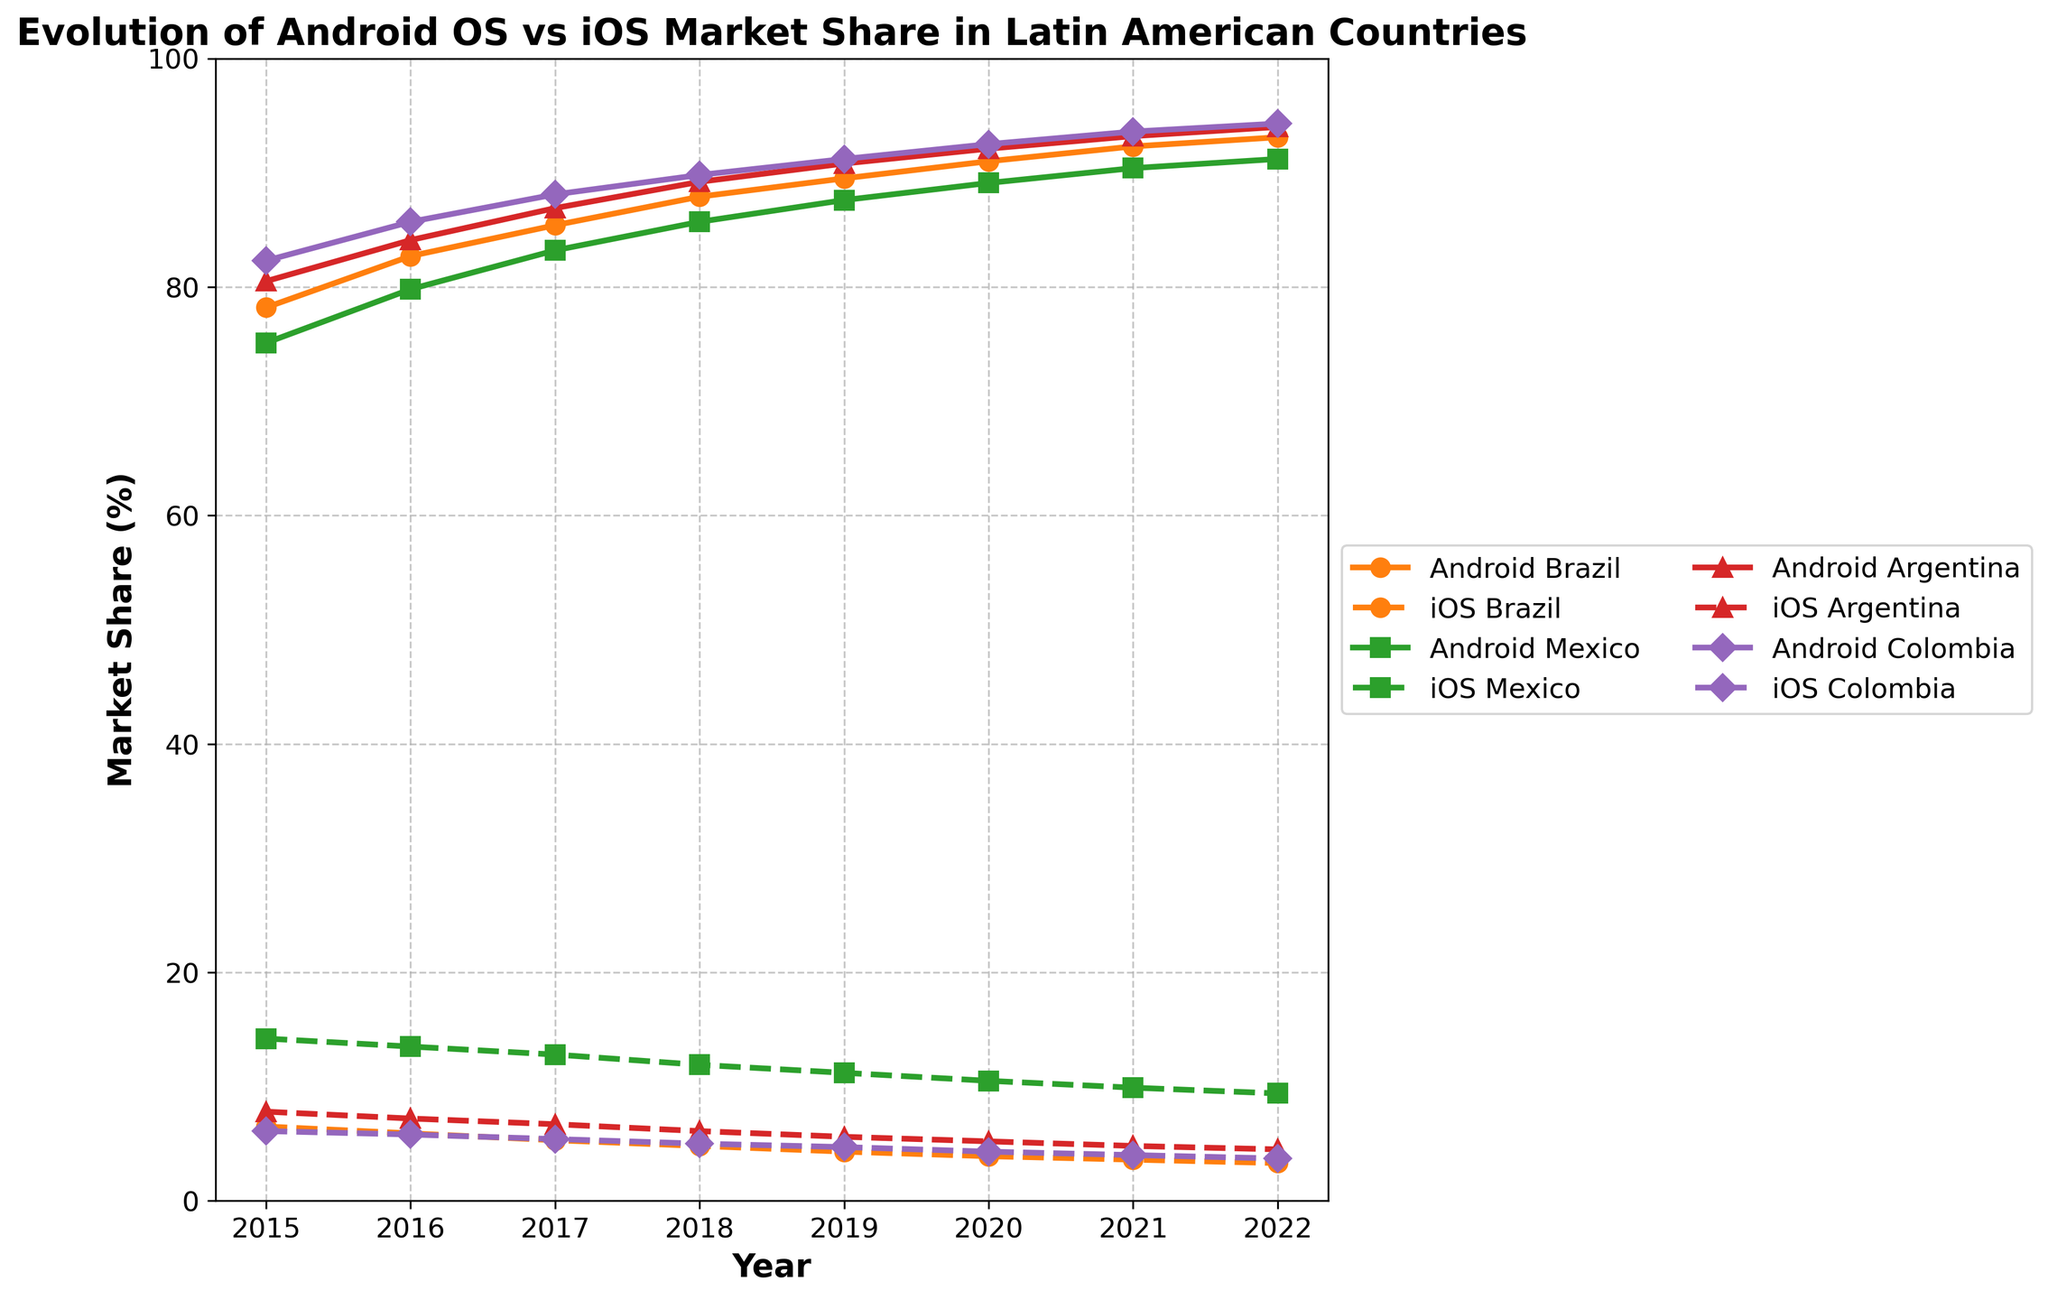How does the market share of Android in Brazil compare to iOS in 2015? In 2015, the market share of Android in Brazil was 78.2% while for iOS it was 6.5%. Comparing these values, Android had a significantly higher market share.
Answer: Android had a significantly higher market share Between 2018 and 2022, which country showed the greatest increase in Android market share? To find the greatest increase, subtract the 2018 Android market share from the 2022 value for each country: Brazil (93.1 - 87.9 = 5.2%), Mexico (91.2 - 85.7 = 5.5%), Argentina (94.0 - 89.2 = 4.8%), and Colombia (94.3 - 89.8 = 4.5%). Mexico showed the greatest increase.
Answer: Mexico Which country had the highest market share for iOS in 2022? By comparing the iOS market share in 2022 across all countries, Brazil = 3.3%, Mexico = 9.4%, Argentina = 4.5%, and Colombia = 3.7%. Mexico had the highest market share for iOS.
Answer: Mexico In which year did Android surpass 90% market share in Argentina? By looking at the data for Argentina, Android surpassed 90% market share in 2019 (90.8%).
Answer: 2019 Compare the growth trend of Android market share in Brazil and Colombia from 2015 to 2022. Both Brazil and Colombia show a steady increase in Android market share over the years. Starting at 78.2% in 2015 for Brazil and reaching 93.1% in 2022. For Colombia, it started at 82.3% in 2015 and reached 94.3% in 2022. While both trends are increasing, Colombia had a slightly higher growth rate.
Answer: Both increasing, but Colombia's growth rate was slightly higher What was the difference in market share between Android and iOS in Mexico in 2020? In 2020, Android market share in Mexico was 89.1% while iOS was 10.5%. The difference is calculated as 89.1% - 10.5% = 78.6%.
Answer: 78.6% On average, what was the iOS market share in Brazil over the given years? To find the average iOS market share in Brazil: (6.5 + 5.9 + 5.3 + 4.8 + 4.3 + 3.9 + 3.6 + 3.3) / 8 = 4.7%.
Answer: 4.7% In which year did iOS market share in Mexico drop below 10%? According to the data, iOS market share in Mexico dropped below 10% in 2021 (9.9%).
Answer: 2021 What are the visual patterns of the Android market share lines across the countries? The Android market share lines for all four countries show a consistent upward trend throughout the years, represented by solid lines. Each country's line uses a distinct color (orange, green, red, purple).
Answer: Upward trend with distinct colors 